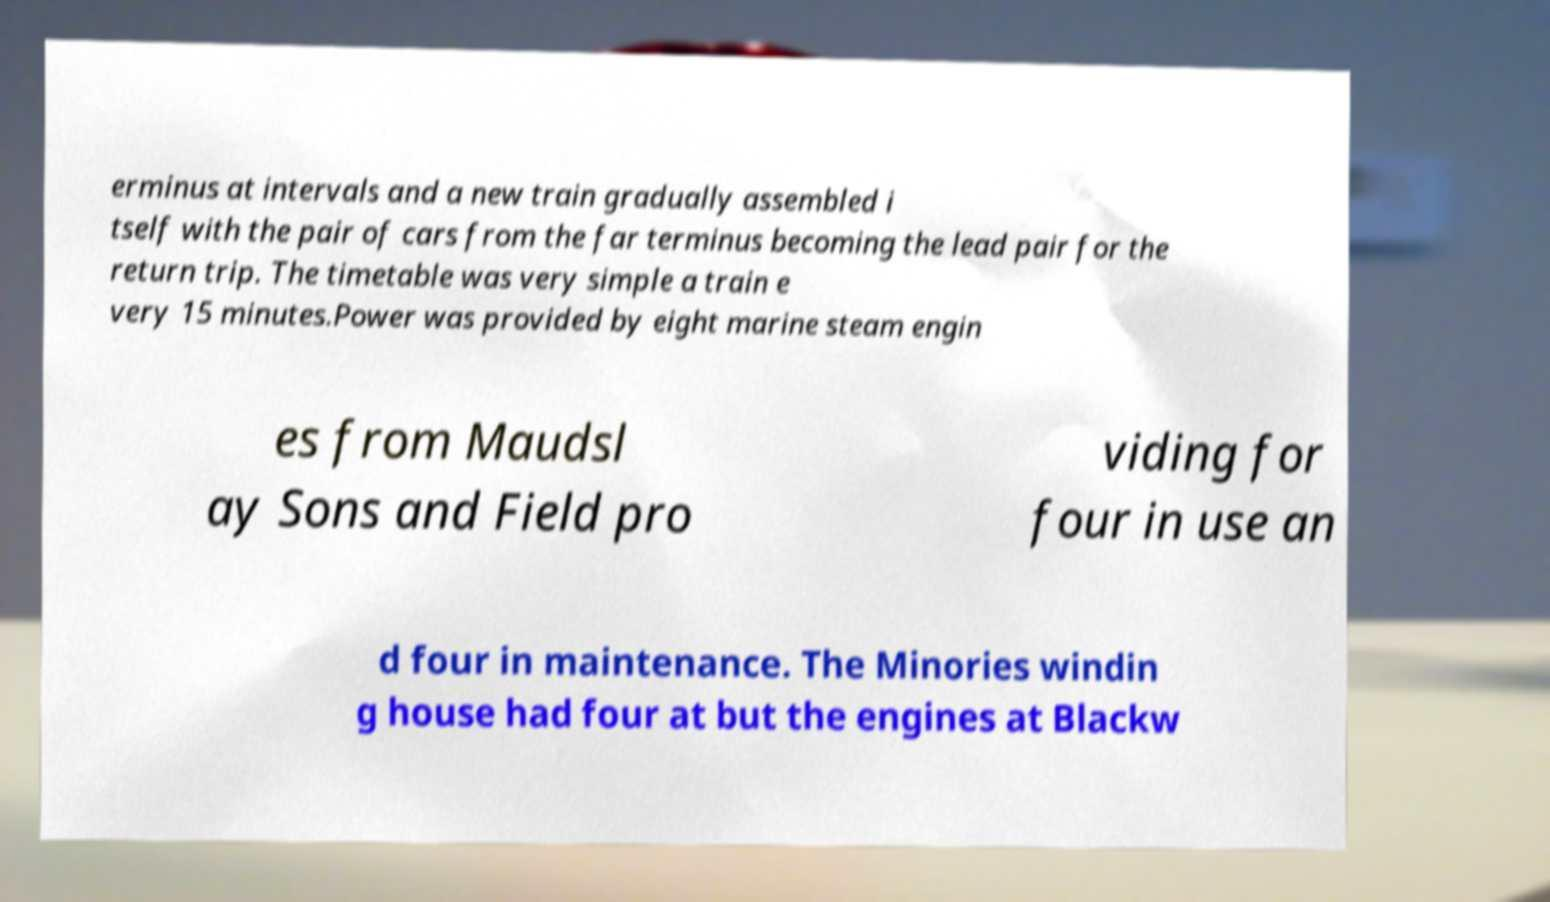What messages or text are displayed in this image? I need them in a readable, typed format. erminus at intervals and a new train gradually assembled i tself with the pair of cars from the far terminus becoming the lead pair for the return trip. The timetable was very simple a train e very 15 minutes.Power was provided by eight marine steam engin es from Maudsl ay Sons and Field pro viding for four in use an d four in maintenance. The Minories windin g house had four at but the engines at Blackw 